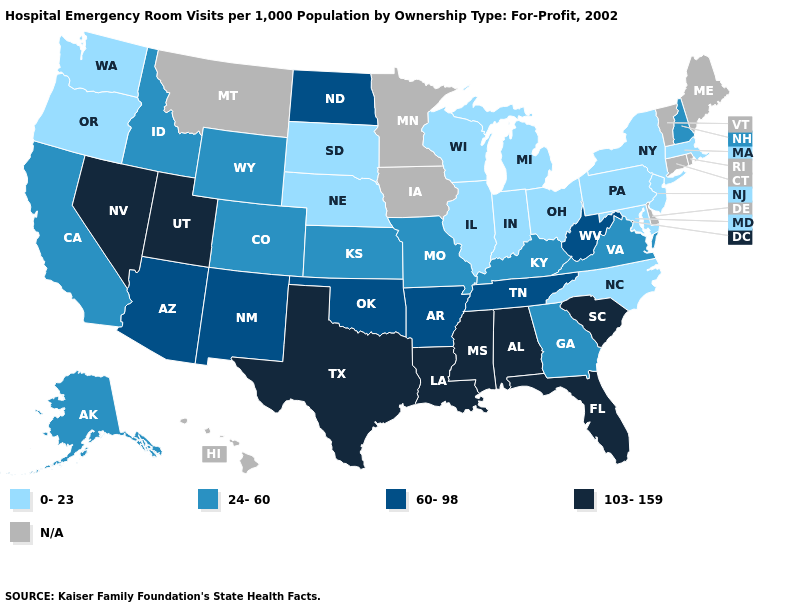What is the lowest value in states that border Kansas?
Answer briefly. 0-23. What is the value of Indiana?
Be succinct. 0-23. Among the states that border Pennsylvania , does West Virginia have the highest value?
Answer briefly. Yes. Among the states that border Arizona , does Nevada have the lowest value?
Give a very brief answer. No. Does Alabama have the highest value in the USA?
Answer briefly. Yes. Name the states that have a value in the range 24-60?
Keep it brief. Alaska, California, Colorado, Georgia, Idaho, Kansas, Kentucky, Missouri, New Hampshire, Virginia, Wyoming. What is the lowest value in states that border Oklahoma?
Give a very brief answer. 24-60. Name the states that have a value in the range 0-23?
Give a very brief answer. Illinois, Indiana, Maryland, Massachusetts, Michigan, Nebraska, New Jersey, New York, North Carolina, Ohio, Oregon, Pennsylvania, South Dakota, Washington, Wisconsin. Does Pennsylvania have the lowest value in the USA?
Quick response, please. Yes. What is the value of Colorado?
Give a very brief answer. 24-60. Does the map have missing data?
Keep it brief. Yes. What is the value of Pennsylvania?
Concise answer only. 0-23. Is the legend a continuous bar?
Be succinct. No. Among the states that border Wyoming , which have the highest value?
Concise answer only. Utah. 